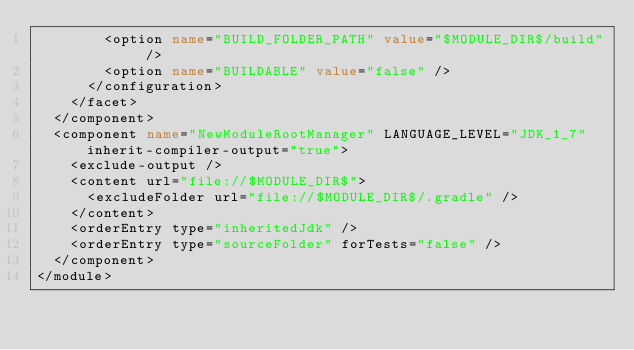Convert code to text. <code><loc_0><loc_0><loc_500><loc_500><_XML_>        <option name="BUILD_FOLDER_PATH" value="$MODULE_DIR$/build" />
        <option name="BUILDABLE" value="false" />
      </configuration>
    </facet>
  </component>
  <component name="NewModuleRootManager" LANGUAGE_LEVEL="JDK_1_7" inherit-compiler-output="true">
    <exclude-output />
    <content url="file://$MODULE_DIR$">
      <excludeFolder url="file://$MODULE_DIR$/.gradle" />
    </content>
    <orderEntry type="inheritedJdk" />
    <orderEntry type="sourceFolder" forTests="false" />
  </component>
</module></code> 